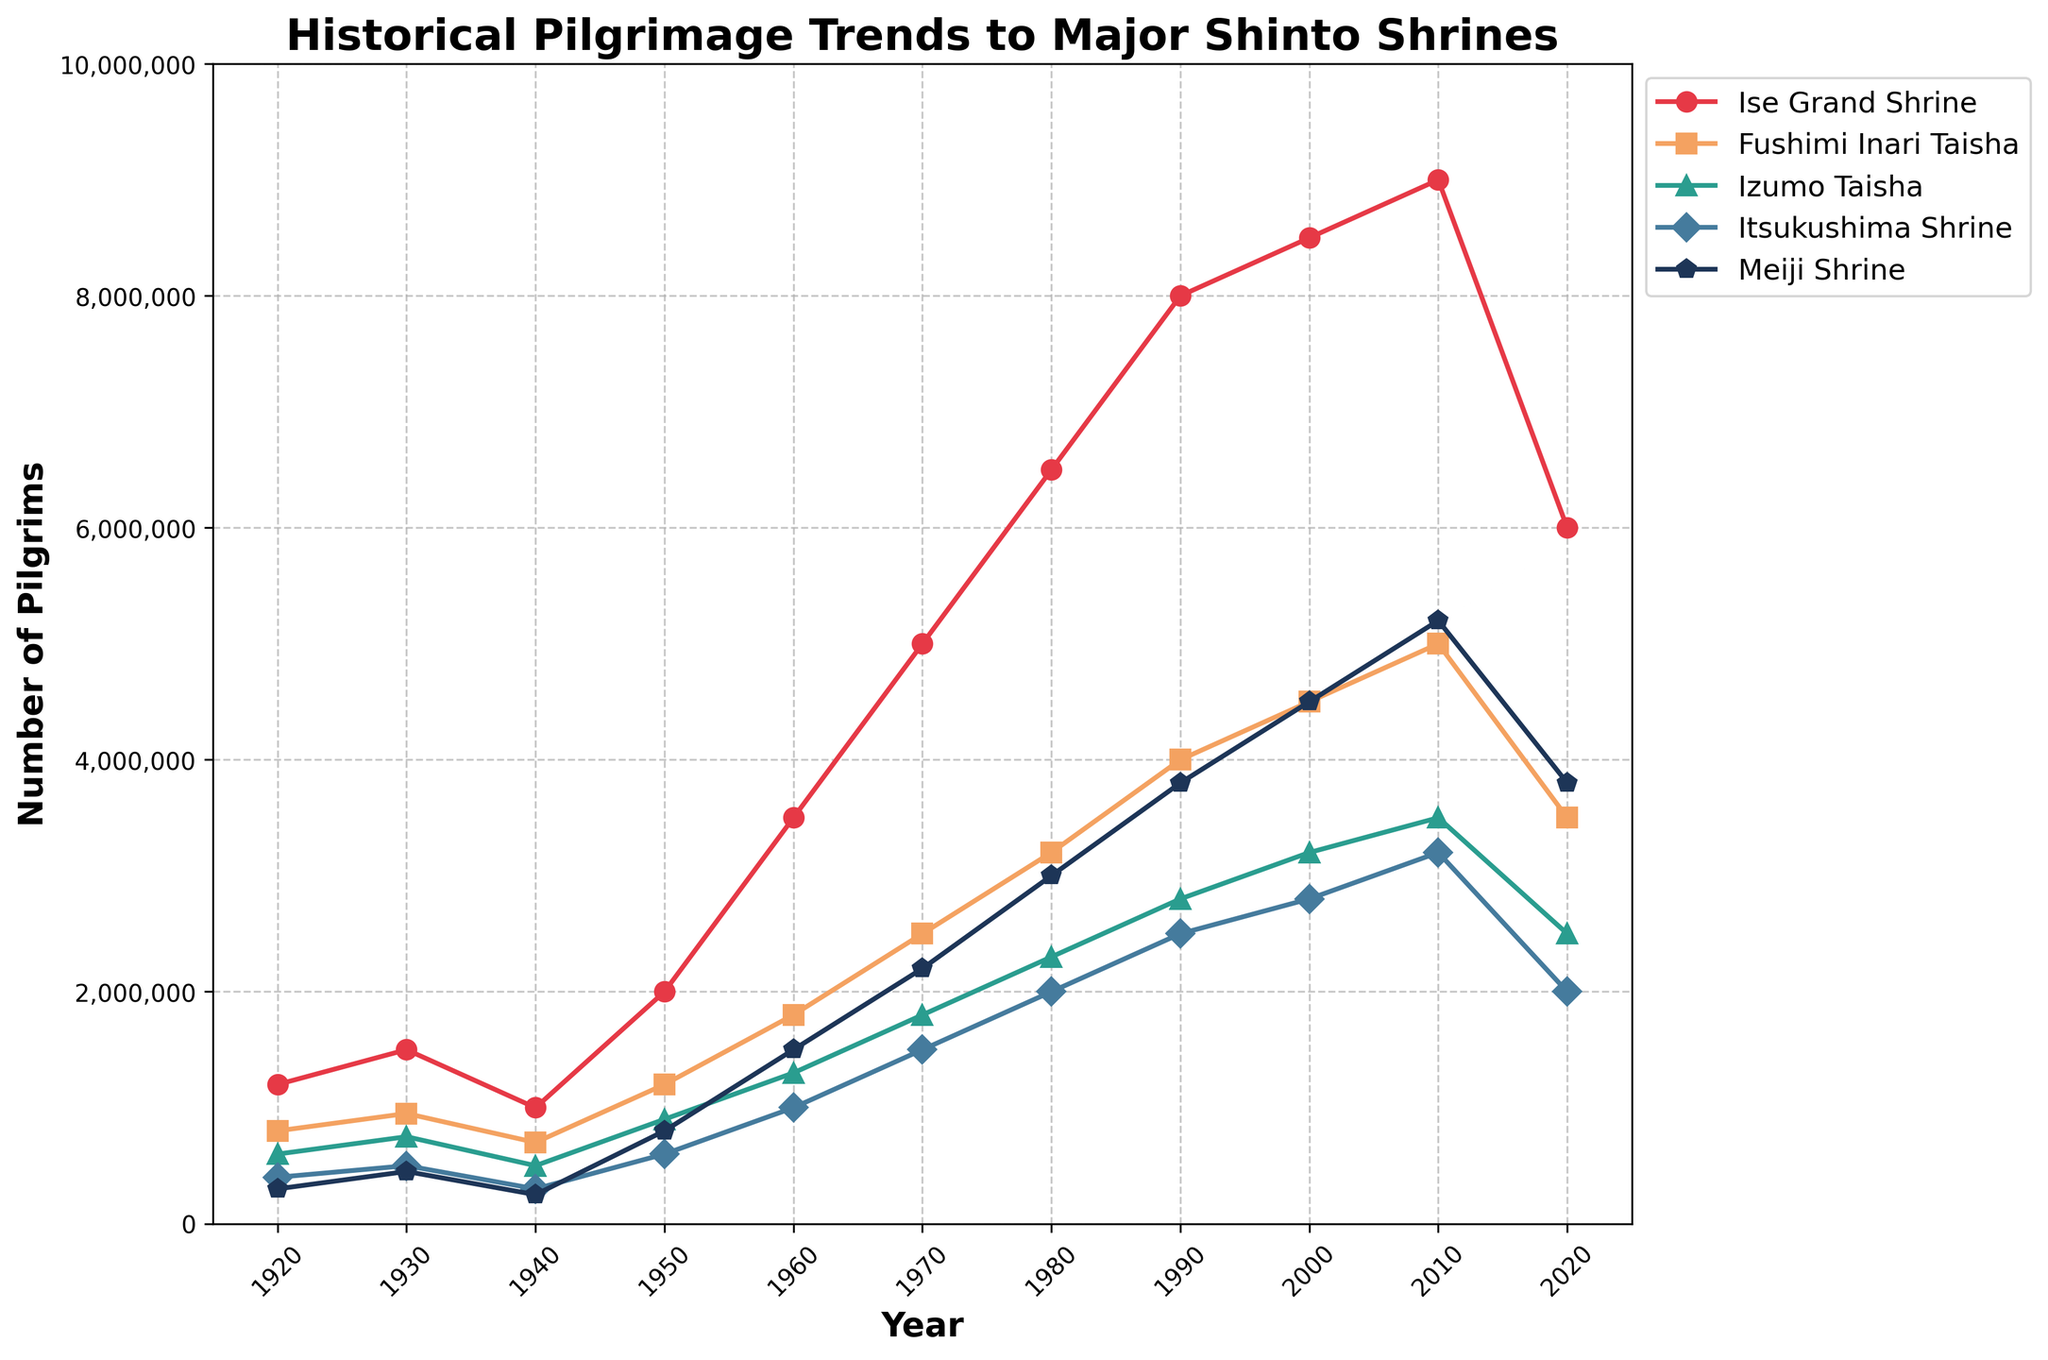Which shrine had the highest number of pilgrims in 2020? To determine this, look at the plot for the year 2020 and compare the end values for each shrine. The highest value belongs to Ise Grand Shrine.
Answer: Ise Grand Shrine What is the difference in the number of pilgrims between Ise Grand Shrine and Meiji Shrine in 2020? Locate the number of pilgrims at Ise Grand Shrine and Meiji Shrine in 2020 on the plot. Subtract the number of pilgrims at Meiji Shrine from those at Ise Grand Shrine: 6,000,000 - 3,800,000 = 2,200,000.
Answer: 2,200,000 Which shrine had the lowest number of pilgrims in 1960? Review the plot at the year 1960 and find the lowest data point among all shrines. That lowest value corresponds to Itsukushima Shrine.
Answer: Itsukushima Shrine How many more pilgrims did Fushimi Inari Taisha have in 1980 compared to 1950? Find the number of pilgrims for Fushimi Inari Taisha in both 1980 and 1950. Then, subtract the 1950 figure from the 1980 figure: 3,200,000 - 1,200,000 = 2,000,000.
Answer: 2,000,000 What is the sum of the number of pilgrims for all shrines in 1970? Add the number of pilgrims for each shrine in the year 1970: 5,000,000 (Ise Grand Shrine) + 2,500,000 (Fushimi Inari Taisha) + 1,800,000 (Izumo Taisha) + 1,500,000 (Itsukushima Shrine) + 2,200,000 (Meiji Shrine) = 13,000,000.
Answer: 13,000,000 What was the average number of pilgrims at Ise Grand Shrine between 1920 and 2020? Sum the values for Ise Grand Shrine from 1920 to 2020 and divide by the number of data points: (1,200,000 + 1,500,000 + 1,000,000 + 2,000,000 + 3,500,000 + 5,000,000 + 6,500,000 + 8,000,000 + 8,500,000 + 9,000,000 + 6,000,000) / 11 ≈ 4,522,727.
Answer: ≈ 4,522,727 Which shrine saw the highest increase in the number of pilgrims from 1960 to 2010? Compare the difference in the number of pilgrims between 1960 and 2010 for all shrines. Ise Grand Shrine increased from 3,500,000 to 9,000,000, which is an increase of 5,500,000. No other shrine had a higher increase.
Answer: Ise Grand Shrine In which year did Meiji Shrine surpass 2,000,000 pilgrims for the first time? Look at the plot for Meiji Shrine and identify the year where the number of pilgrims first exceeds 2,000,000. This occurs between 1960 and 1970, specifically in 1970.
Answer: 1970 Compare the trend in the number of pilgrims at Ise Grand Shrine and Itsukushima Shrine from 1980 to 2020. Observe the plots of both shrines from 1980 to 2020. Ise Grand Shrine shows a steady increase followed by a decline in 2020. Itsukushima Shrine also increases but at a slower rate, peaking in 2000 before declining in 2020.
Answer: Ise Grand Shrine shows a steeper increase and larger decline 